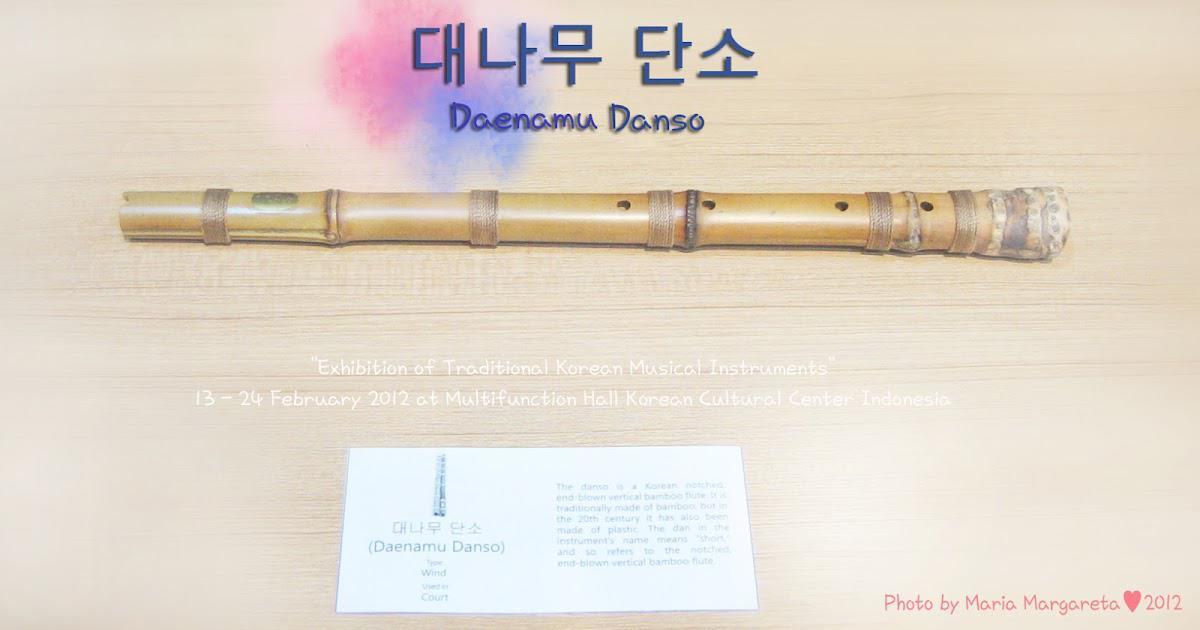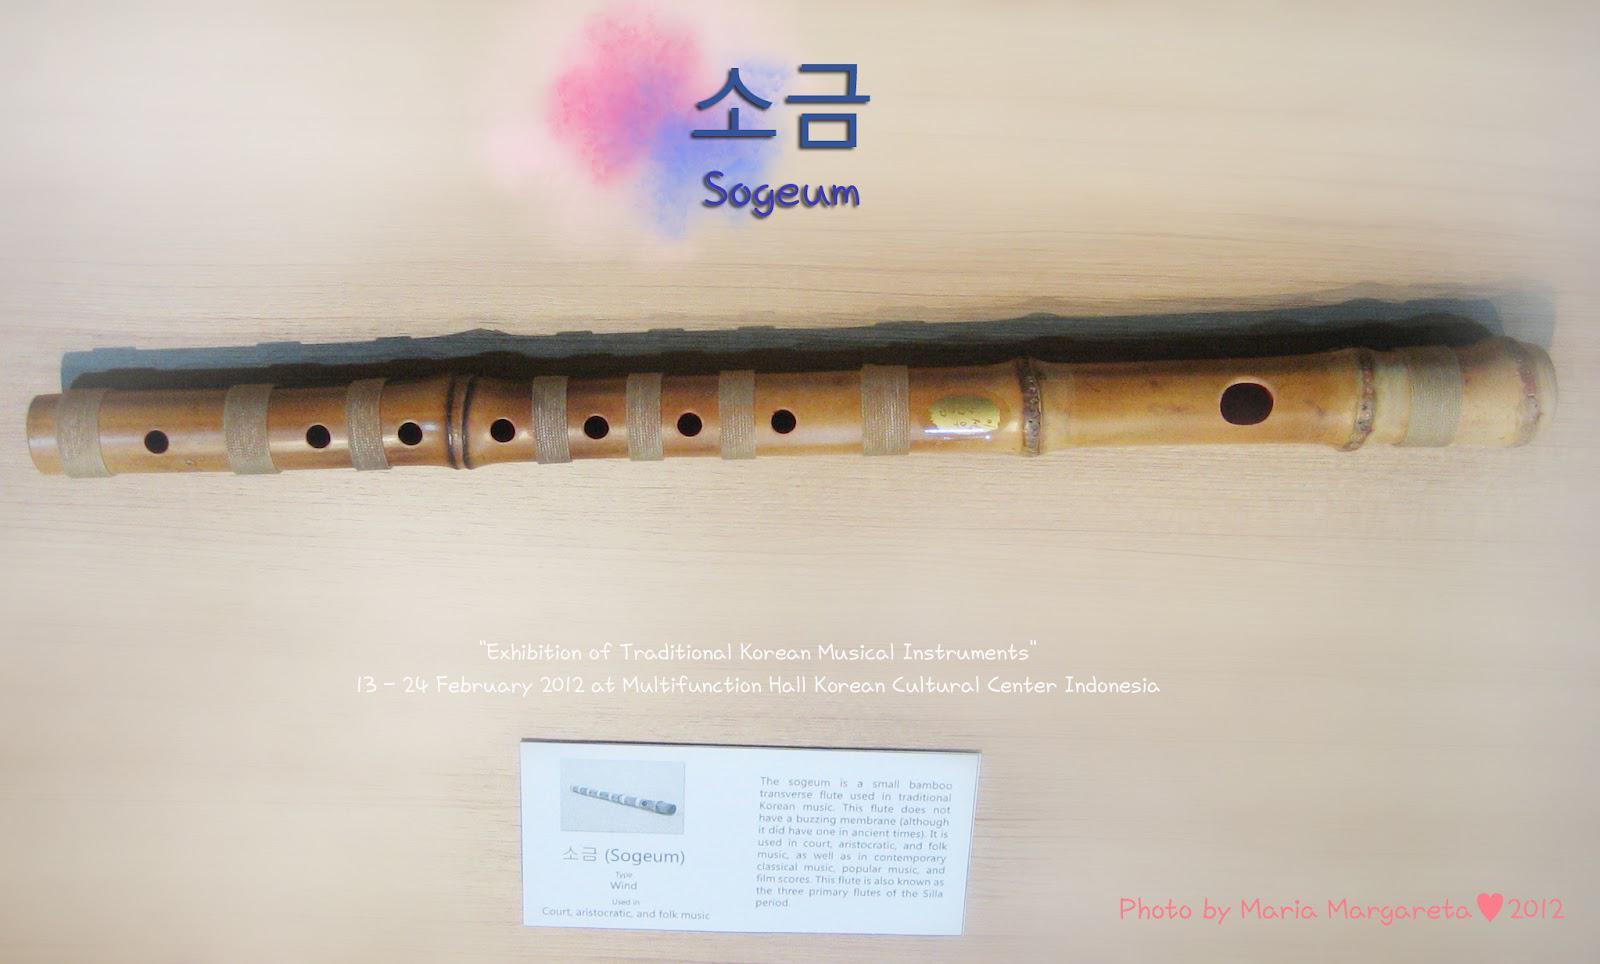The first image is the image on the left, the second image is the image on the right. Considering the images on both sides, is "Each image shows one bamboo flute displayed horizontally above a white card and beneath Asian characters superimposed over pink and blue color patches." valid? Answer yes or no. Yes. The first image is the image on the left, the second image is the image on the right. For the images displayed, is the sentence "Each of the instruments has an information card next to it." factually correct? Answer yes or no. Yes. 